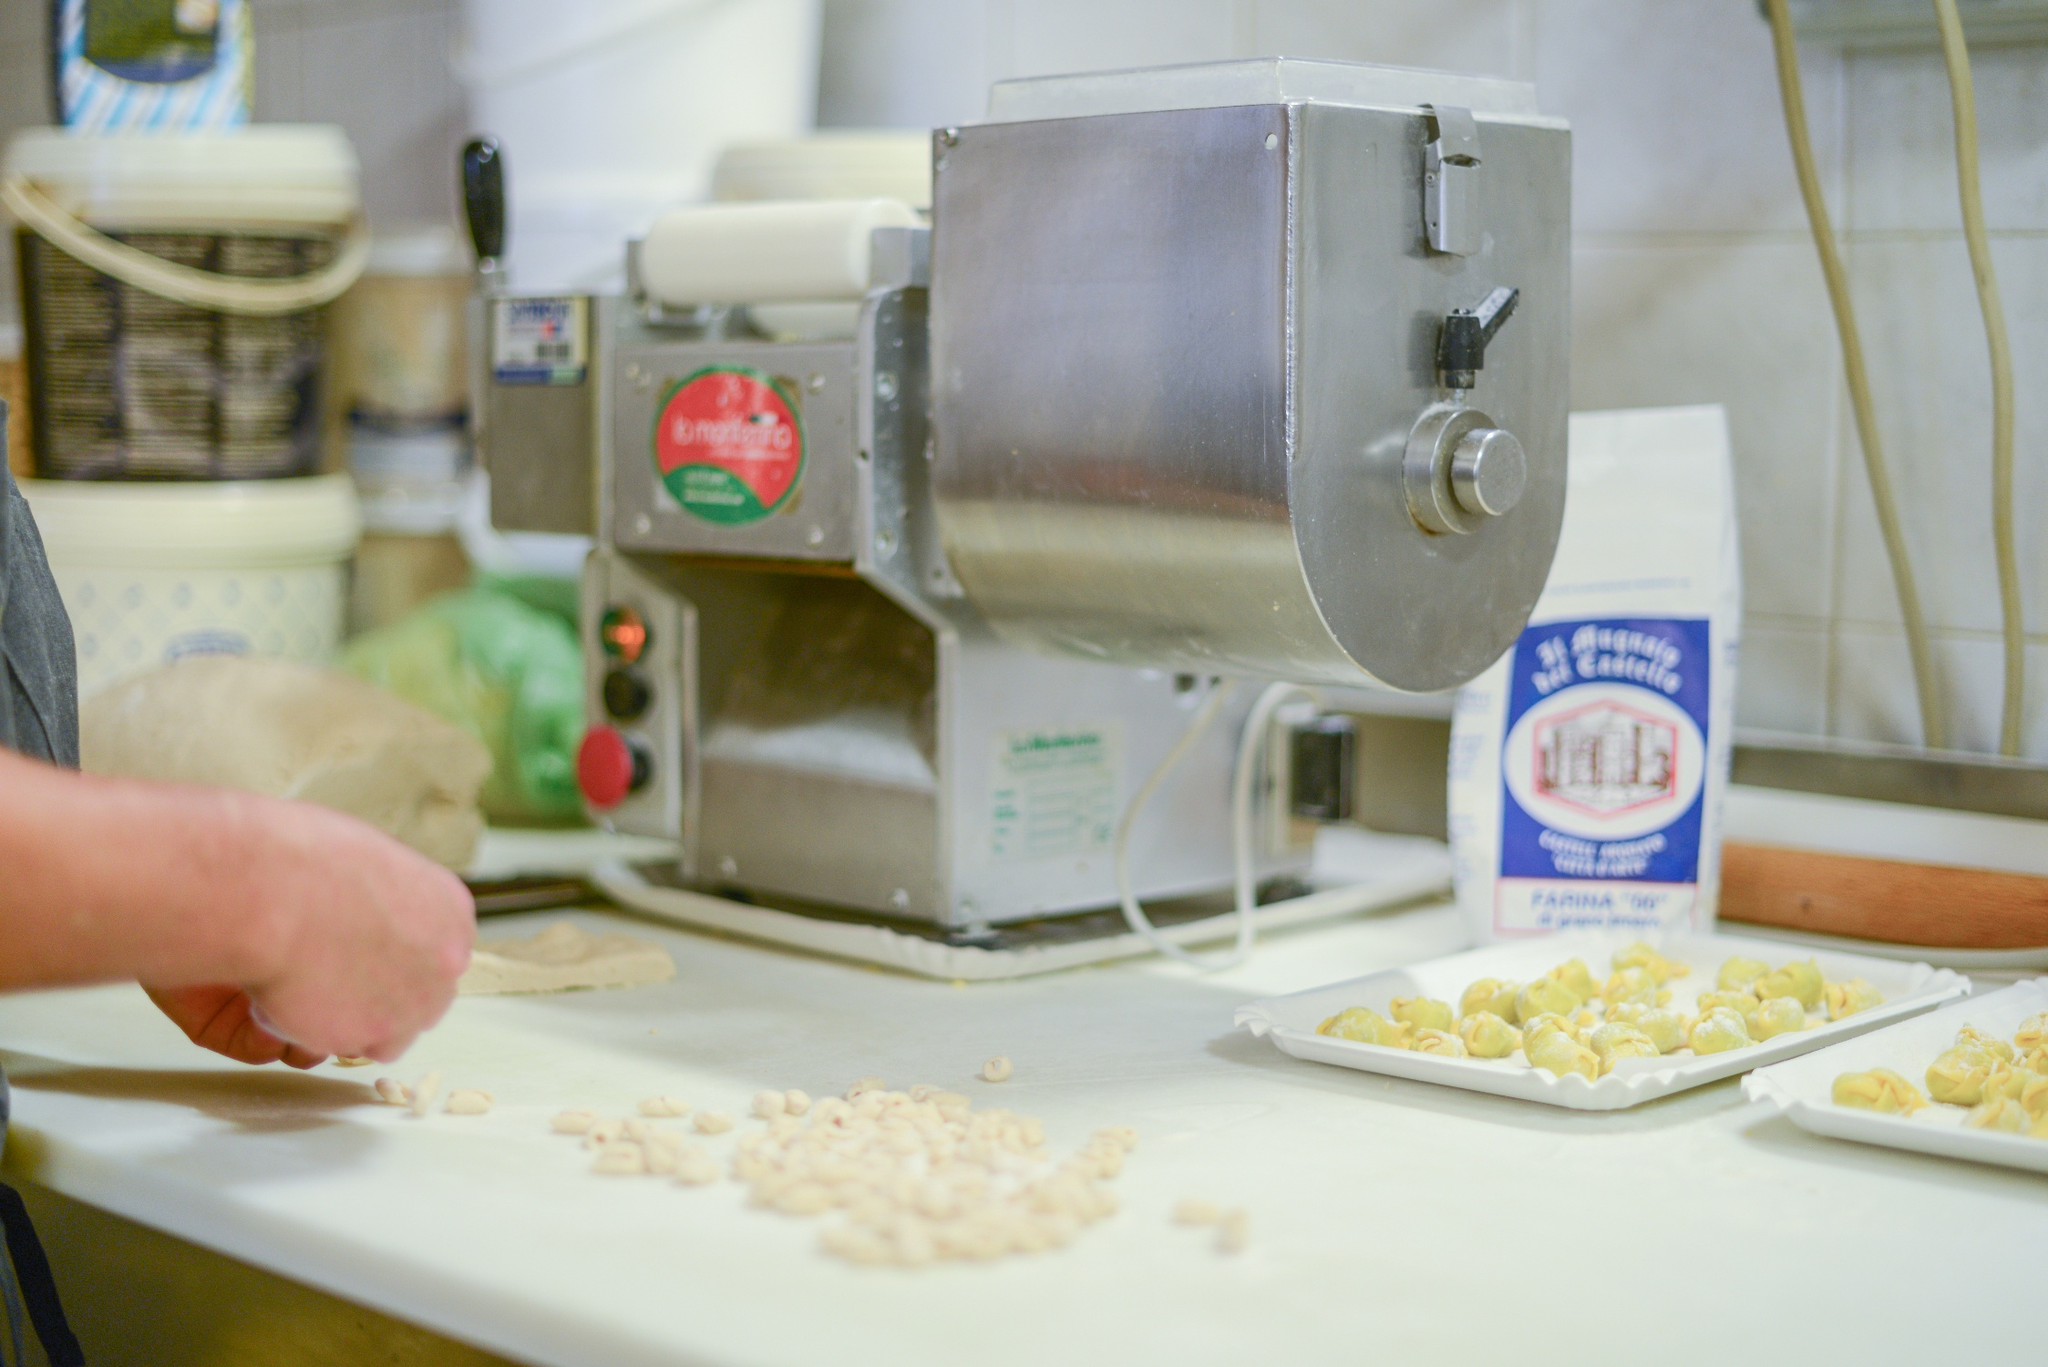What's happening in this kitchen? The kitchen is abuzz with activity as someone engages in the intricate process of making fresh pasta. With a pasta machine, marked with the label 'La monferrina', as the centerpiece, the setup reveals a keen dedication to culinary arts. Various shapes of light yellow pasta are being prepared on a tray, reflecting the creator’s skill and patience. The countertop hosts a white bowl with a blue rim and a bag of 'La Molisana Farina Tipo 00' flour, essential ingredients for pasta-making. The white tiled walls and organized shelf in the background add a touch of homeliness and practicality. 